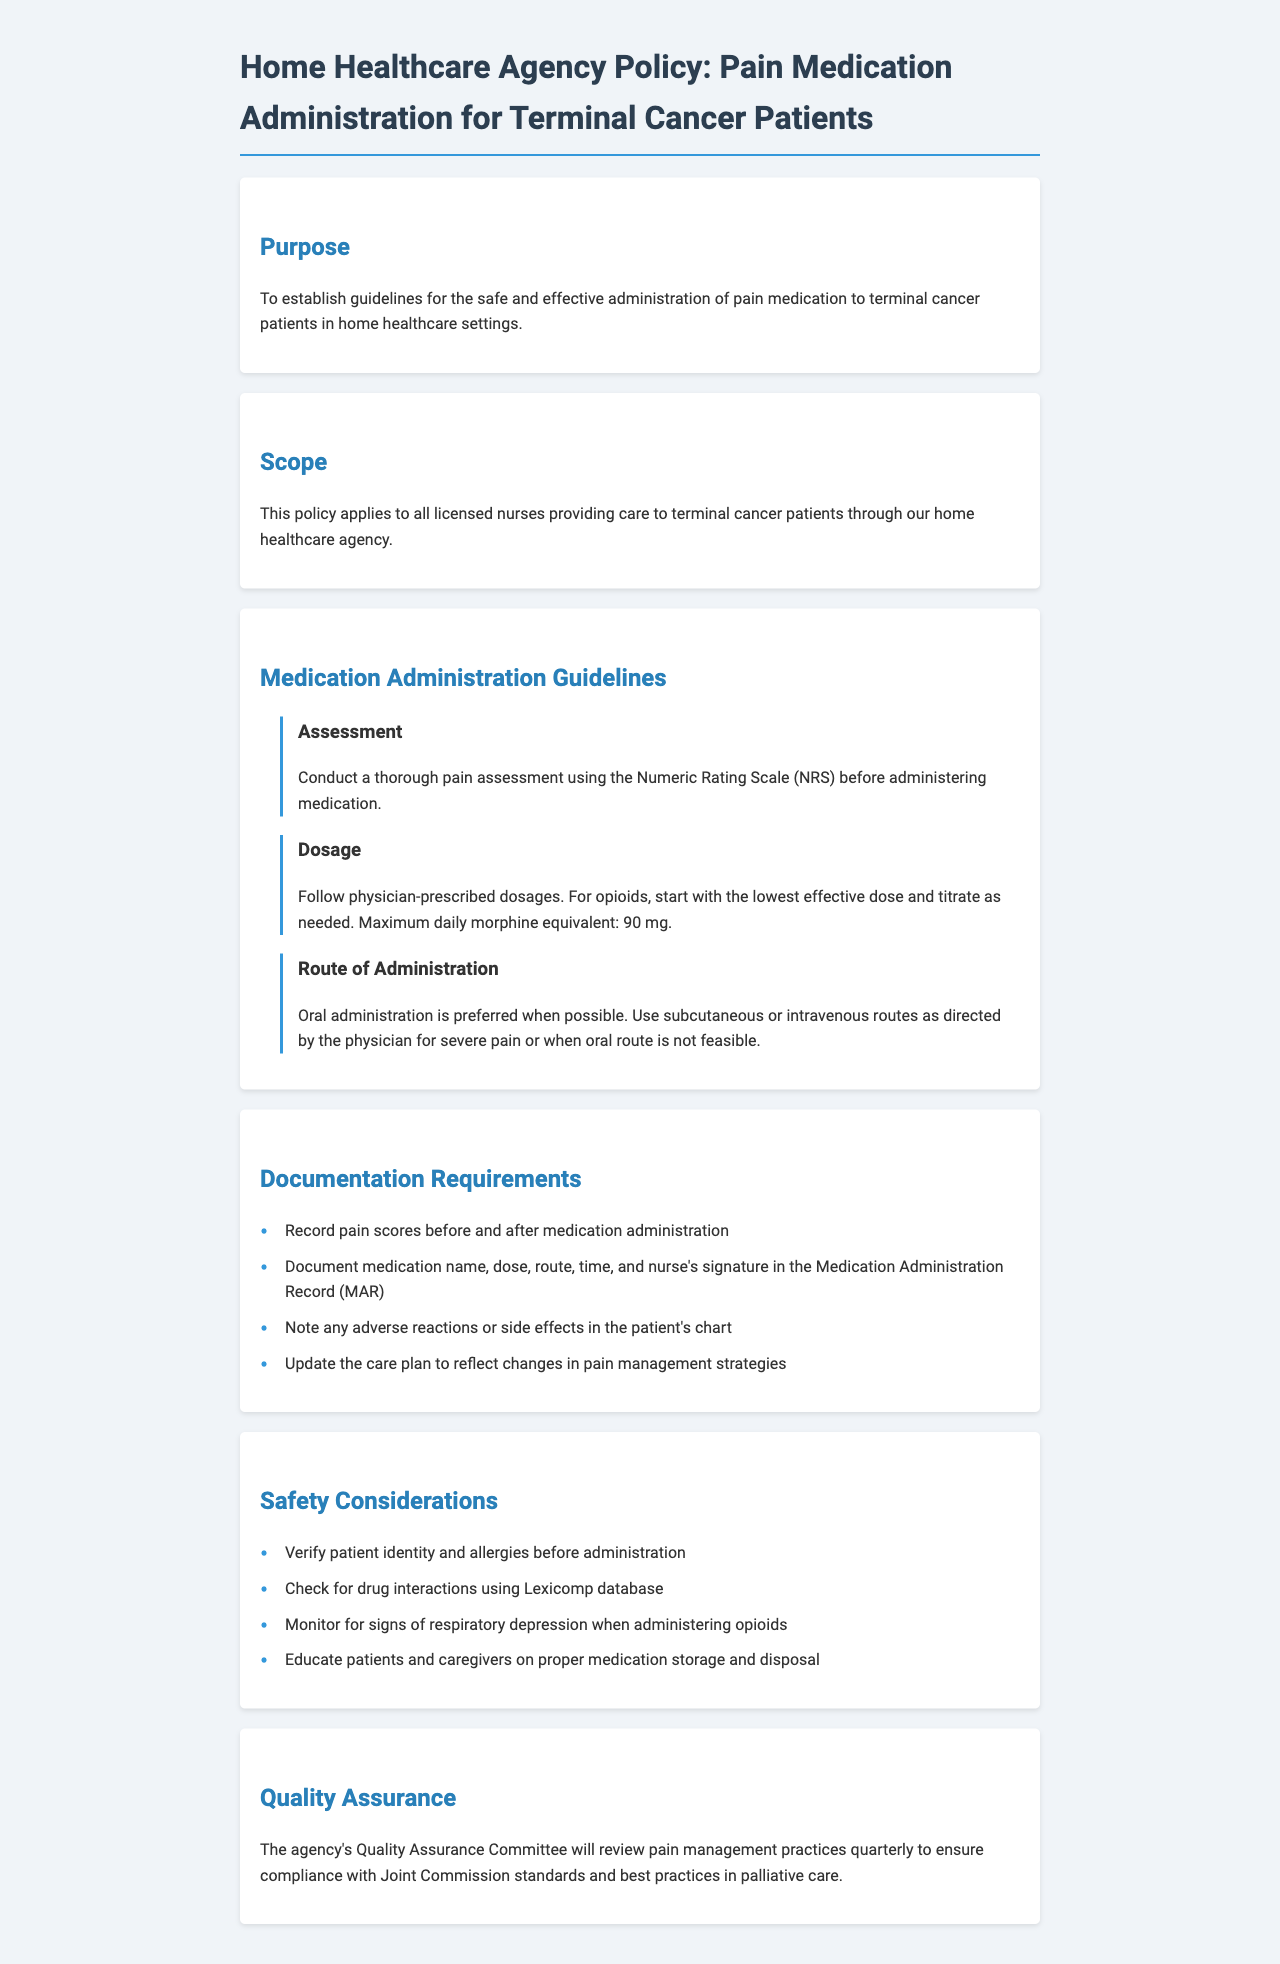What is the maximum daily morphine equivalent? The policy specifies a maximum daily morphine equivalent of 90 mg for terminal cancer patients.
Answer: 90 mg What is the preferred route of administration for pain medication? The document states that oral administration is preferred when possible.
Answer: Oral What scale is used for pain assessment? The Numeric Rating Scale (NRS) is used according to the guidelines for pain assessment before medication administration.
Answer: Numeric Rating Scale What should be documented before and after medication administration? Pain scores before and after medication administration must be recorded.
Answer: Pain scores Who will review pain management practices quarterly? The agency's Quality Assurance Committee is responsible for reviewing pain management practices quarterly.
Answer: Quality Assurance Committee What is required for checking patient safety before administration? Verifying patient identity and allergies is required for patient safety prior to medication administration.
Answer: Verify identity and allergies What type of medication should be titrated as needed? Opioids should be started at the lowest effective dose and titrated as needed according to the dosage guidelines.
Answer: Opioids What should be noted about any adverse reactions? Any adverse reactions or side effects must be documented in the patient's chart.
Answer: Adverse reactions What is included in the Medication Administration Record (MAR)? The MAR should include medication name, dose, route, time, and nurse's signature.
Answer: Medication name, dose, route, time, nurse's signature 